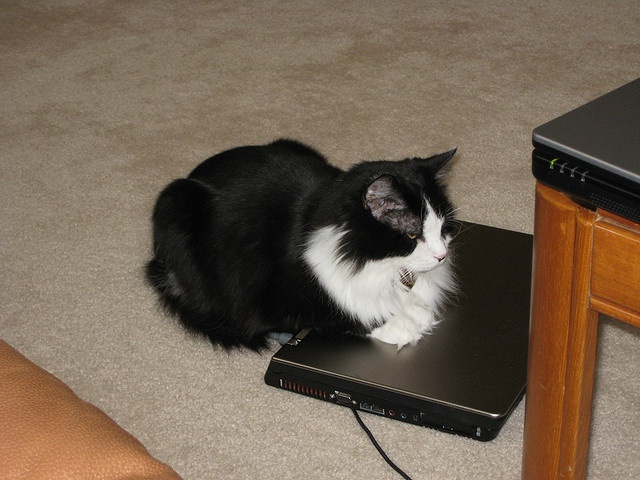Describe the objects in this image and their specific colors. I can see cat in gray, black, lightgray, and darkgray tones, laptop in gray and black tones, and laptop in gray, black, and darkgray tones in this image. 